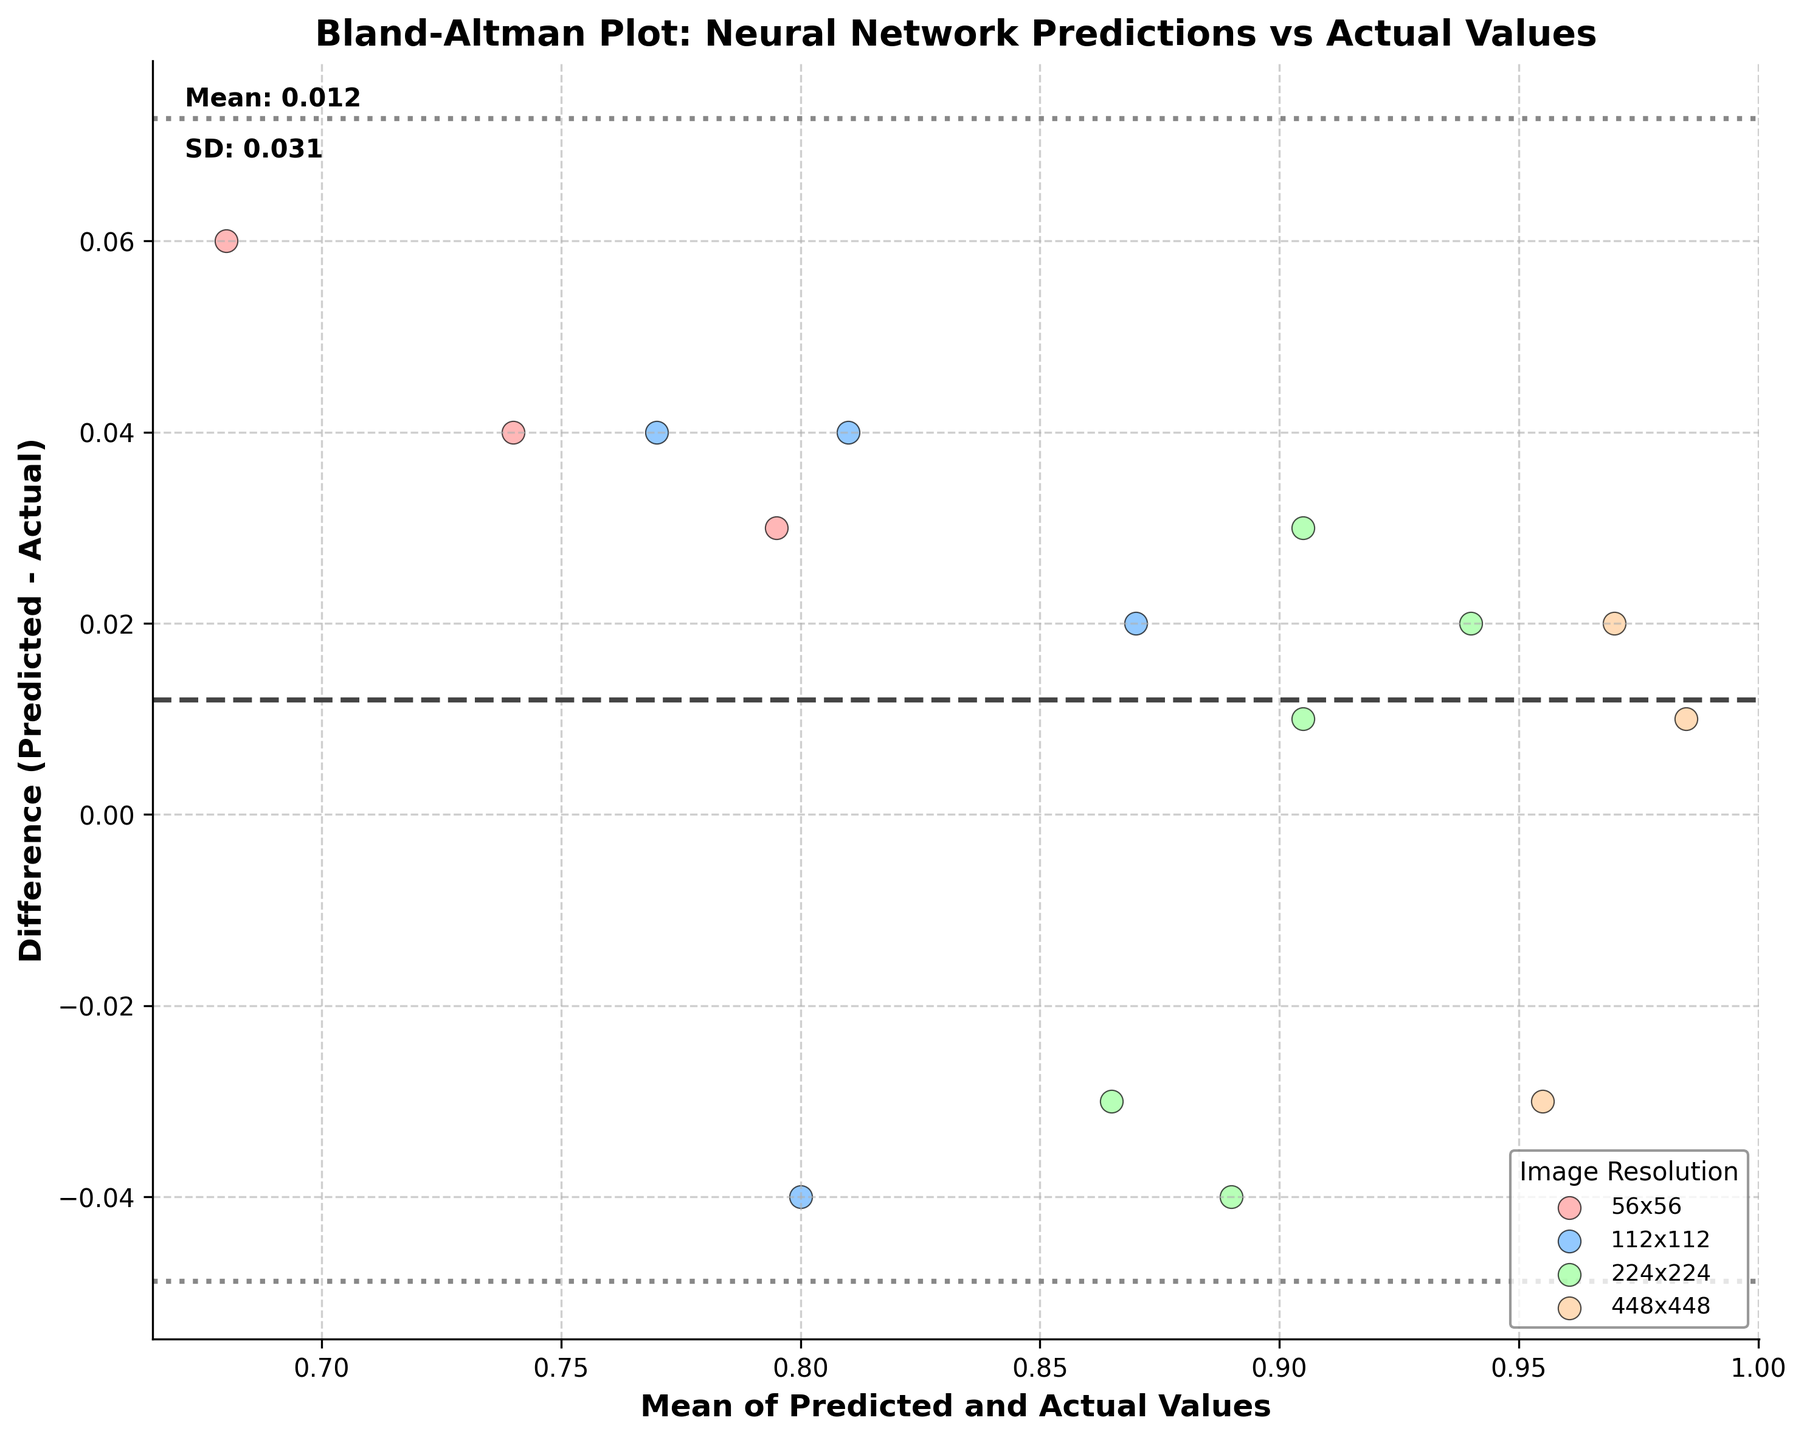What is the title of the plot? The title of the plot is visible at the top. It states "Bland-Altman Plot: Neural Network Predictions vs Actual Values."
Answer: Bland-Altman Plot: Neural Network Predictions vs Actual Values What are the labels of the axes? The x-axis is labeled as "Mean of Predicted and Actual Values," and the y-axis is labeled as "Difference (Predicted - Actual)."
Answer: Mean of Predicted and Actual Values, Difference (Predicted - Actual) Which image resolution has the most data points in the plot? By observing the scatter points and their respective colors, we see that the 224x224 resolution (green dots) appears the most frequently.
Answer: 224x224 What is the mean difference between the predicted and actual values? The mean difference is annotated textually on the plot, stating "Mean: 0.003." It is also shown by the horizontal dashed line.
Answer: 0.003 Which image resolution indicates higher differences between predictions and actual values? The largest differences between predicted and actual values are for the 56x56 resolution (red dots), which show the widest spread from the mean difference line.
Answer: 56x56 Approximately what is the standard deviation of the differences? The standard deviation is annotated textually on the plot, stating "SD: 0.045." It is also implied by the distance between the dashed and dotted lines.
Answer: 0.045 How do the biases differ between image resolutions? To determine the bias, we look at the clustering of differences. Lower resolution images (like 56x56) seem to show larger biases (wider spread), while higher resolutions (like 448x448) have smaller biases (narrower spread).
Answer: Lower resolutions have higher biases; higher resolutions have lower biases Are there any image resolutions where the predictions are consistently higher than actual values? Consistent higher predictions would appear as points concentrated above the mean line. For the 56x56 and 112x112 resolutions, most of the points are above the 0-difference line, indicating higher predictions.
Answer: Yes, 56x56 and 112x112 Which image resolution shows the least variability in differences? The 448x448 resolution (orange dots) shows the least variability, as the points are clustered tightly around the mean difference line.
Answer: 448x448 Are any points beyond the 95% limits of agreement? Observing the dotted lines representing ±1.96 SD from the mean, 56x56 resolution data points are near but not beyond these limits.
Answer: No 